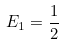Convert formula to latex. <formula><loc_0><loc_0><loc_500><loc_500>E _ { 1 } = \frac { 1 } { 2 }</formula> 